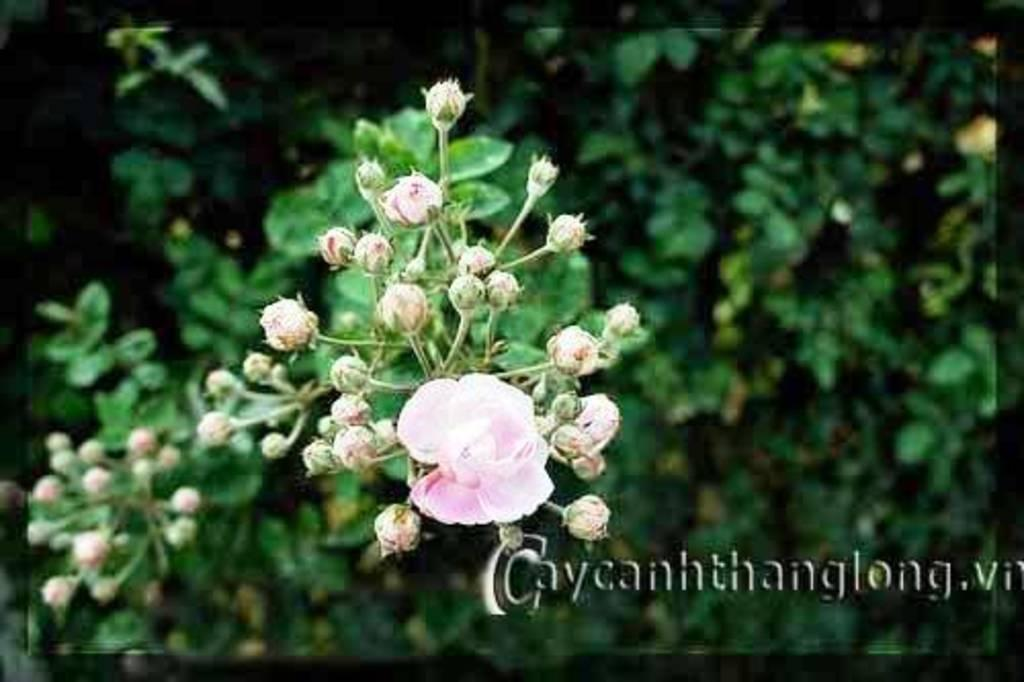What type of living organisms can be seen in the image? Plants can be seen in the image. What specific parts of the plants are visible? The plants have flowers, buds, and leaves. What is the color of the flowers and buds? The flowers and buds are pink in color. Is there any text present in the image? Yes, there is some text in the bottom right corner of the image. Can you hear the sound of a rake being used on the plants in the image? There is no sound present in the image, and a rake is not visible or mentioned in the provided facts. 